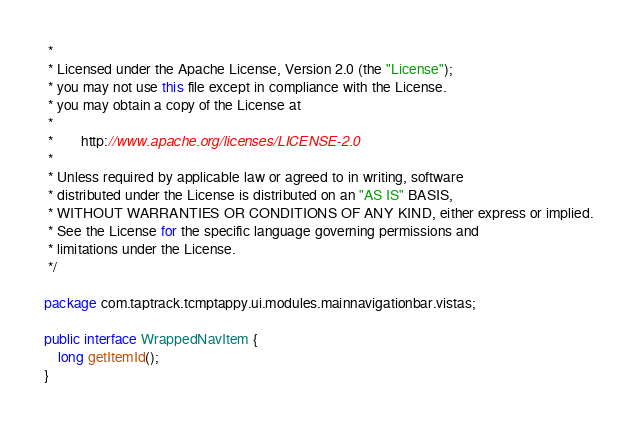Convert code to text. <code><loc_0><loc_0><loc_500><loc_500><_Java_> *
 * Licensed under the Apache License, Version 2.0 (the "License");
 * you may not use this file except in compliance with the License.
 * you may obtain a copy of the License at
 *
 *        http://www.apache.org/licenses/LICENSE-2.0
 *
 * Unless required by applicable law or agreed to in writing, software
 * distributed under the License is distributed on an "AS IS" BASIS,
 * WITHOUT WARRANTIES OR CONDITIONS OF ANY KIND, either express or implied.
 * See the License for the specific language governing permissions and
 * limitations under the License.
 */

package com.taptrack.tcmptappy.ui.modules.mainnavigationbar.vistas;

public interface WrappedNavItem {
    long getItemId();
}
</code> 